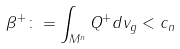<formula> <loc_0><loc_0><loc_500><loc_500>\beta ^ { + } \colon = \int _ { M ^ { n } } Q ^ { + } d v _ { g } < c _ { n }</formula> 